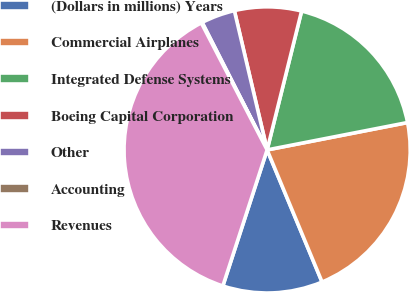Convert chart to OTSL. <chart><loc_0><loc_0><loc_500><loc_500><pie_chart><fcel>(Dollars in millions) Years<fcel>Commercial Airplanes<fcel>Integrated Defense Systems<fcel>Boeing Capital Corporation<fcel>Other<fcel>Accounting<fcel>Revenues<nl><fcel>11.28%<fcel>21.79%<fcel>18.06%<fcel>7.55%<fcel>3.83%<fcel>0.1%<fcel>37.38%<nl></chart> 